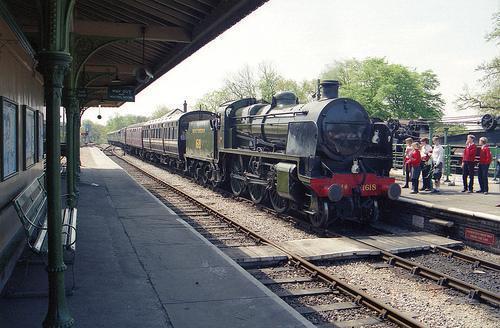How many trains are there?
Give a very brief answer. 1. 